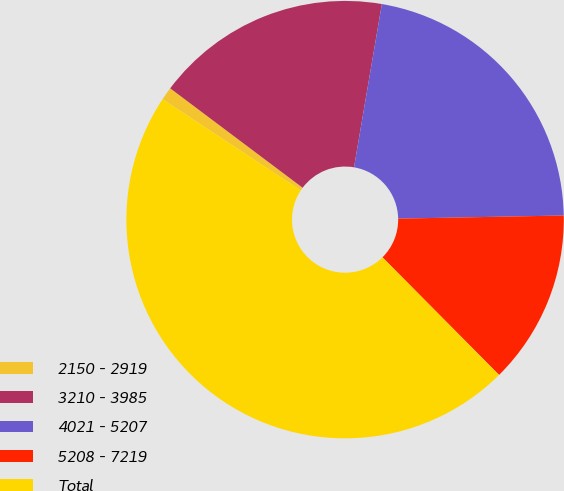Convert chart. <chart><loc_0><loc_0><loc_500><loc_500><pie_chart><fcel>2150 - 2919<fcel>3210 - 3985<fcel>4021 - 5207<fcel>5208 - 7219<fcel>Total<nl><fcel>0.97%<fcel>17.44%<fcel>22.01%<fcel>12.87%<fcel>46.71%<nl></chart> 